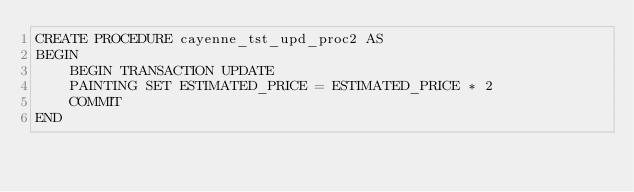<code> <loc_0><loc_0><loc_500><loc_500><_SQL_>CREATE PROCEDURE cayenne_tst_upd_proc2 AS 
BEGIN 
	BEGIN TRANSACTION UPDATE
	PAINTING SET ESTIMATED_PRICE = ESTIMATED_PRICE * 2
	COMMIT 
END
</code> 